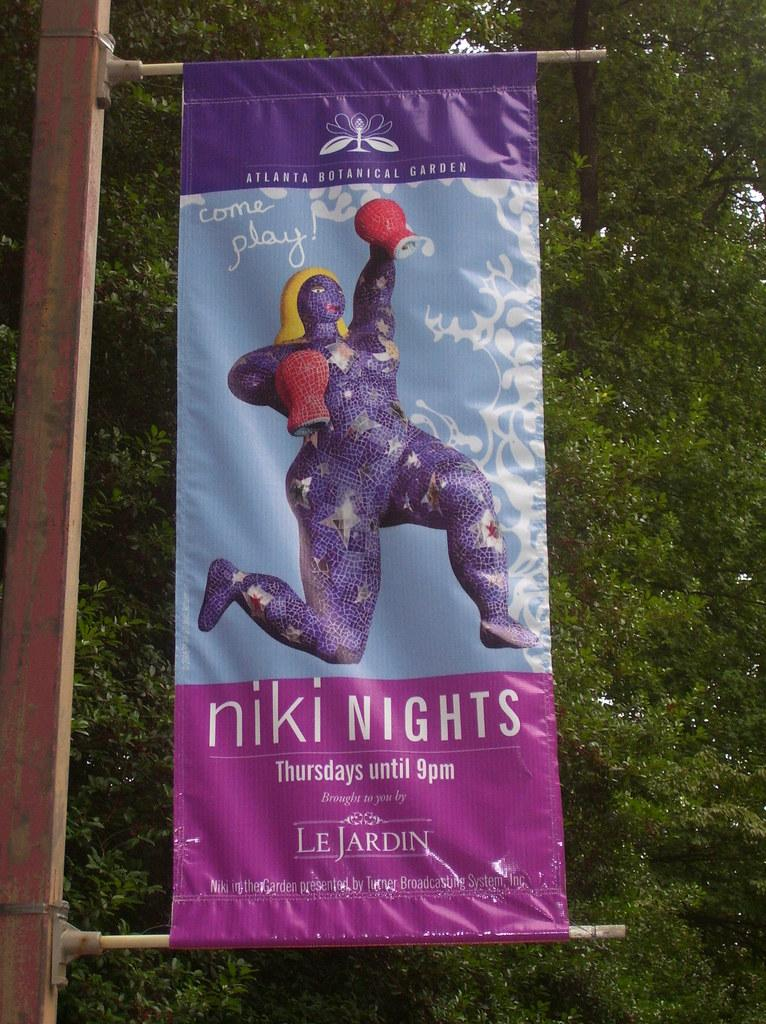<image>
Offer a succinct explanation of the picture presented. a banner hanging on a pole that says 'niki nights' on it 